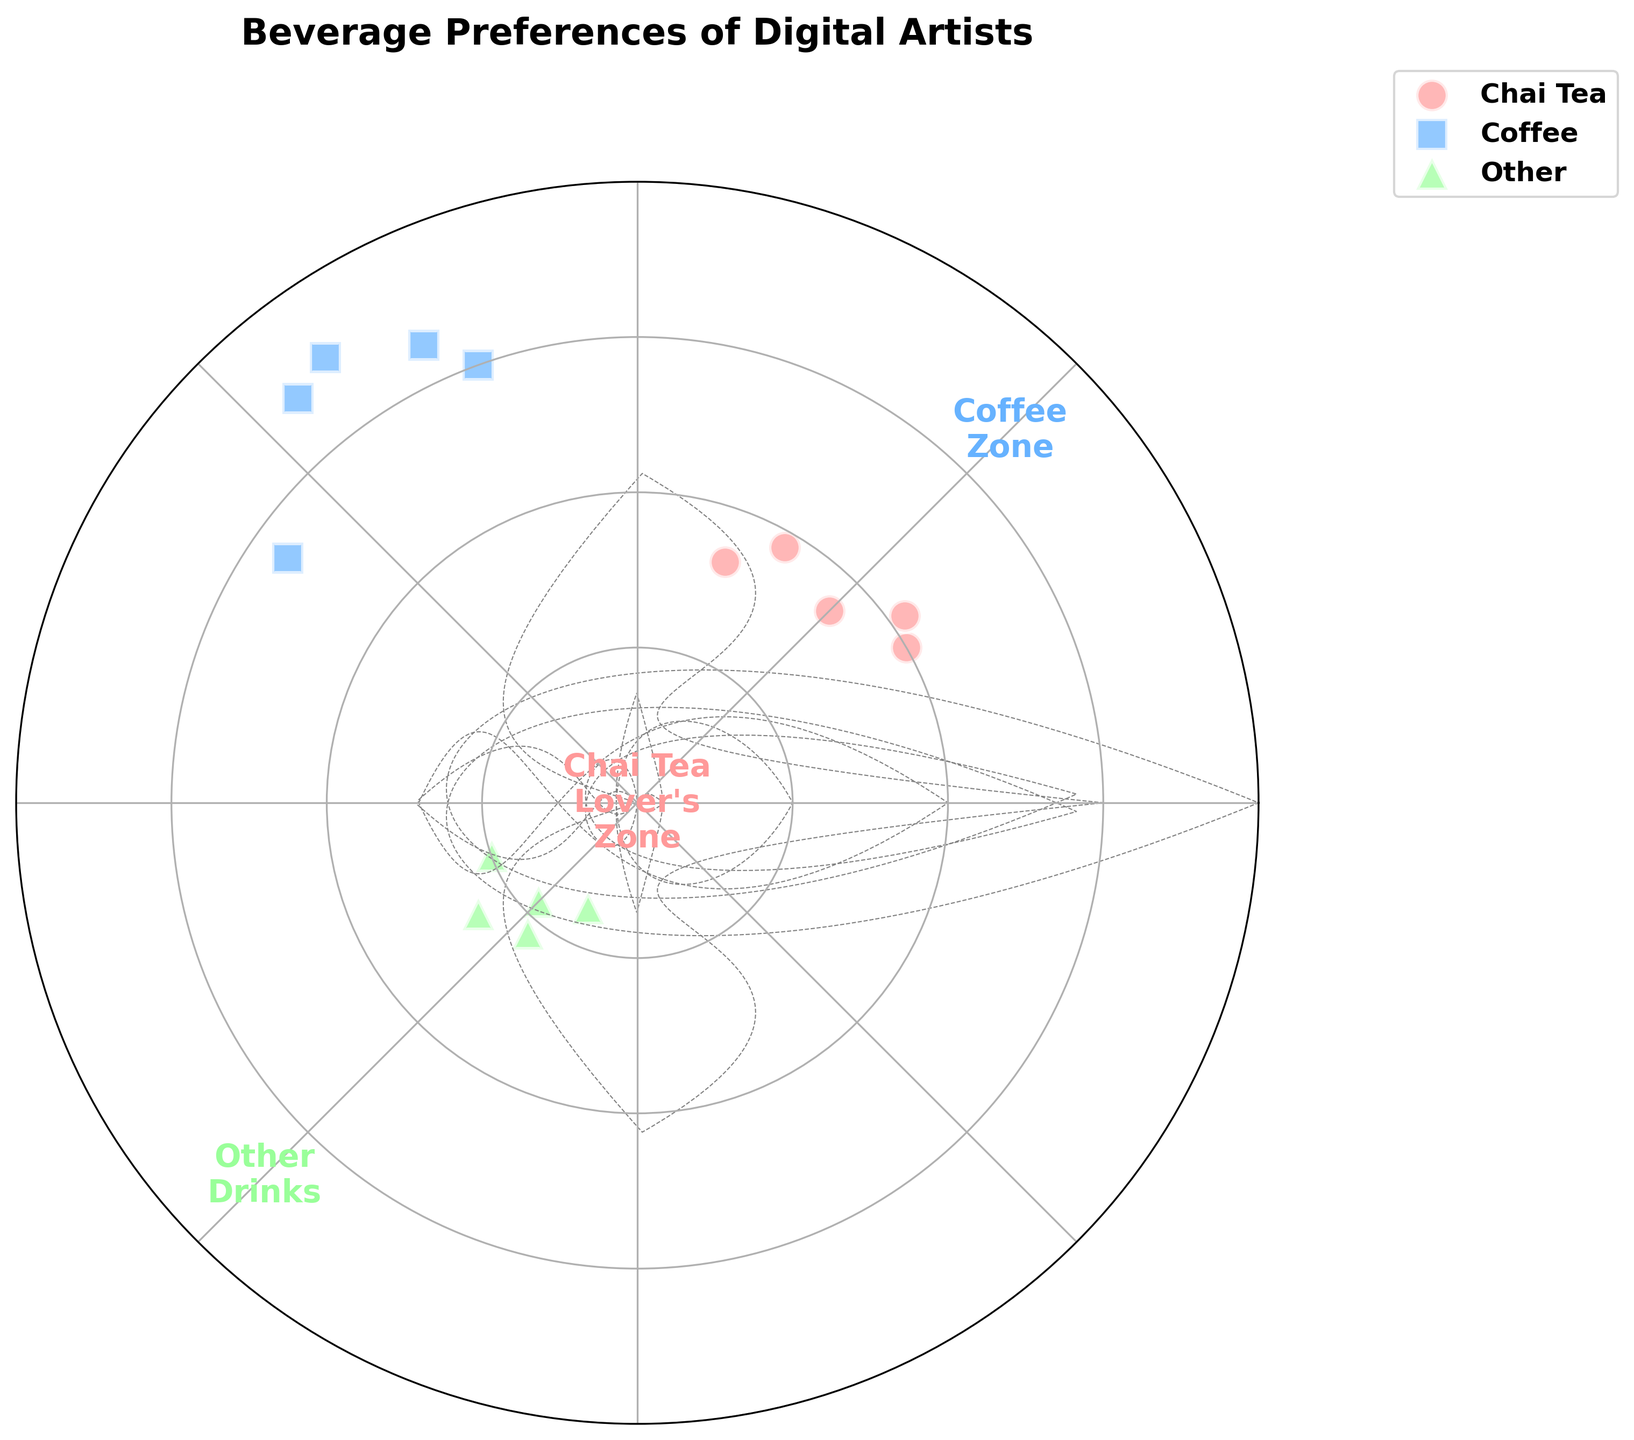What is the title of the Polar Scatter Chart? The title is usually found at the top of the chart and it helps to understand the subject of the figure.
Answer: Beverage Preferences of Digital Artists How many data points are plotted for Coffee? By observing the scatter plot, count the number of markers that represent coffee. Each marker corresponds to one data point in the Coffee category.
Answer: 5 Which category has the highest average radius value? To determine this, calculate the average radius for each category and compare them. Coffee data points have high values, while Other drinks have low values.
Answer: Coffee How are the data points spread across different categories in terms of angle? To answer this, observe the distribution of marker points visually referenced to the angles specified. Coffee points are clustered between 110 and 145 degrees, Chai Tea between 30 and 70 degrees, and Other between 200 and 245 degrees.
Answer: Chai Tea: 30-70°, Coffee: 110-145°, Other: 200-245° Which category has the lowest median radius value? First, arrange the radius values for each category and find the median value for them: 
- Chai Tea: [33, 35, 38, 40, 42]
- Coffee: [55, 60, 65, 68, 70]
- Other: [15, 18, 20, 22, 25]
The median value for each is:
- Chai Tea: 38
- Coffee: 65
- Other: 20
Other has the lowest median radius.
Answer: Other What is the maximum radius value for the Chai Tea category? Look at all the radius values for Chai Tea and find the maximum one among them: [40, 42, 35, 38, 33].
Answer: 42 Between Chai Tea and Coffee, which category has a more diverse spread in radius values? A diverse spread can be intuitively interpreted by observing the range of radius values. Chai Tea has a radius range of [33 - 42], while Coffee has [55 - 70], indicating Coffee has a larger spread.
Answer: Coffee How are the categories visually distinguished in the plot? Identify how different visual elements are used to separate categories: distinct colors, shapes, and placements in the polar chart are used to represent Chai Tea, Coffee, and Other.
Answer: By colors, markers, and placement on the angles Which two categories have overlapping angle values and what are those values? By observing the angle ranges plotted, identify overlaps. Chai Tea has angles from 30 to 70 degrees, while Coffee ranges from 110 to 145 degrees, and there is no overlap between these ranges.
Answer: No overlap What characterizes the sapce marked "Chai Tea Lover's Zone" on the plot? Note the annotation areas and corresponding radius and angles. The "Chai Tea Lover's Zone" centers on Chai Tea's data ranging from around 30-70 degrees and radius of around 30-42.
Answer: Low radius, 30-70 degree 